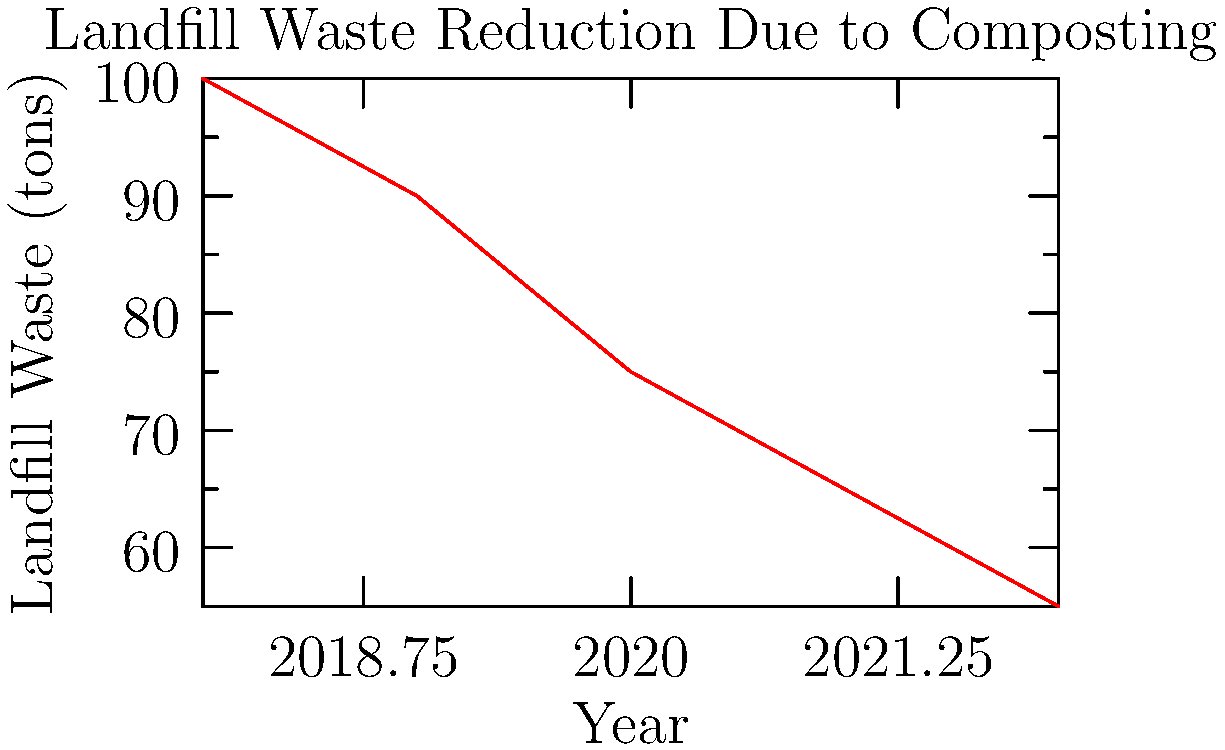Based on the line graph showing landfill waste reduction due to composting efforts, calculate the average annual decrease in landfill waste from 2018 to 2022. To calculate the average annual decrease in landfill waste:

1. Calculate total decrease:
   2018 waste: 100 tons
   2022 waste: 55 tons
   Total decrease = 100 - 55 = 45 tons

2. Calculate number of years:
   2022 - 2018 = 4 years

3. Calculate average annual decrease:
   Average annual decrease = Total decrease ÷ Number of years
   $$ \text{Average annual decrease} = \frac{45 \text{ tons}}{4 \text{ years}} = 11.25 \text{ tons/year} $$

Therefore, the average annual decrease in landfill waste from 2018 to 2022 is 11.25 tons per year.
Answer: 11.25 tons/year 